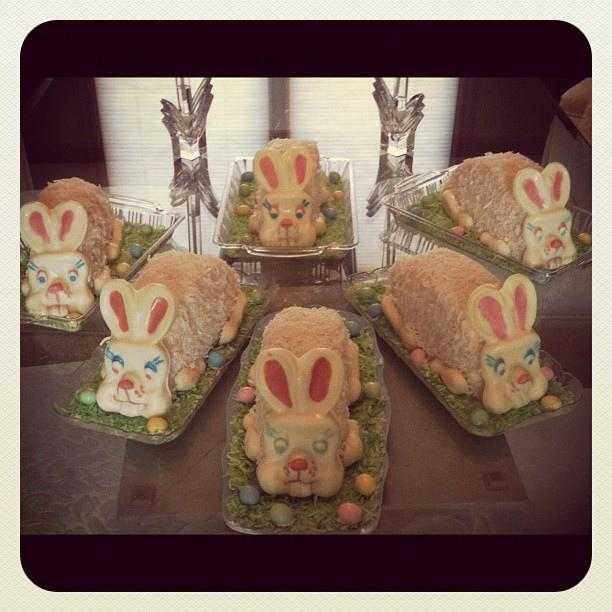What kind of animals are these cakes prepared to the shape of? Please explain your reasoning. rabbit. These are in the shape of a bunny. 